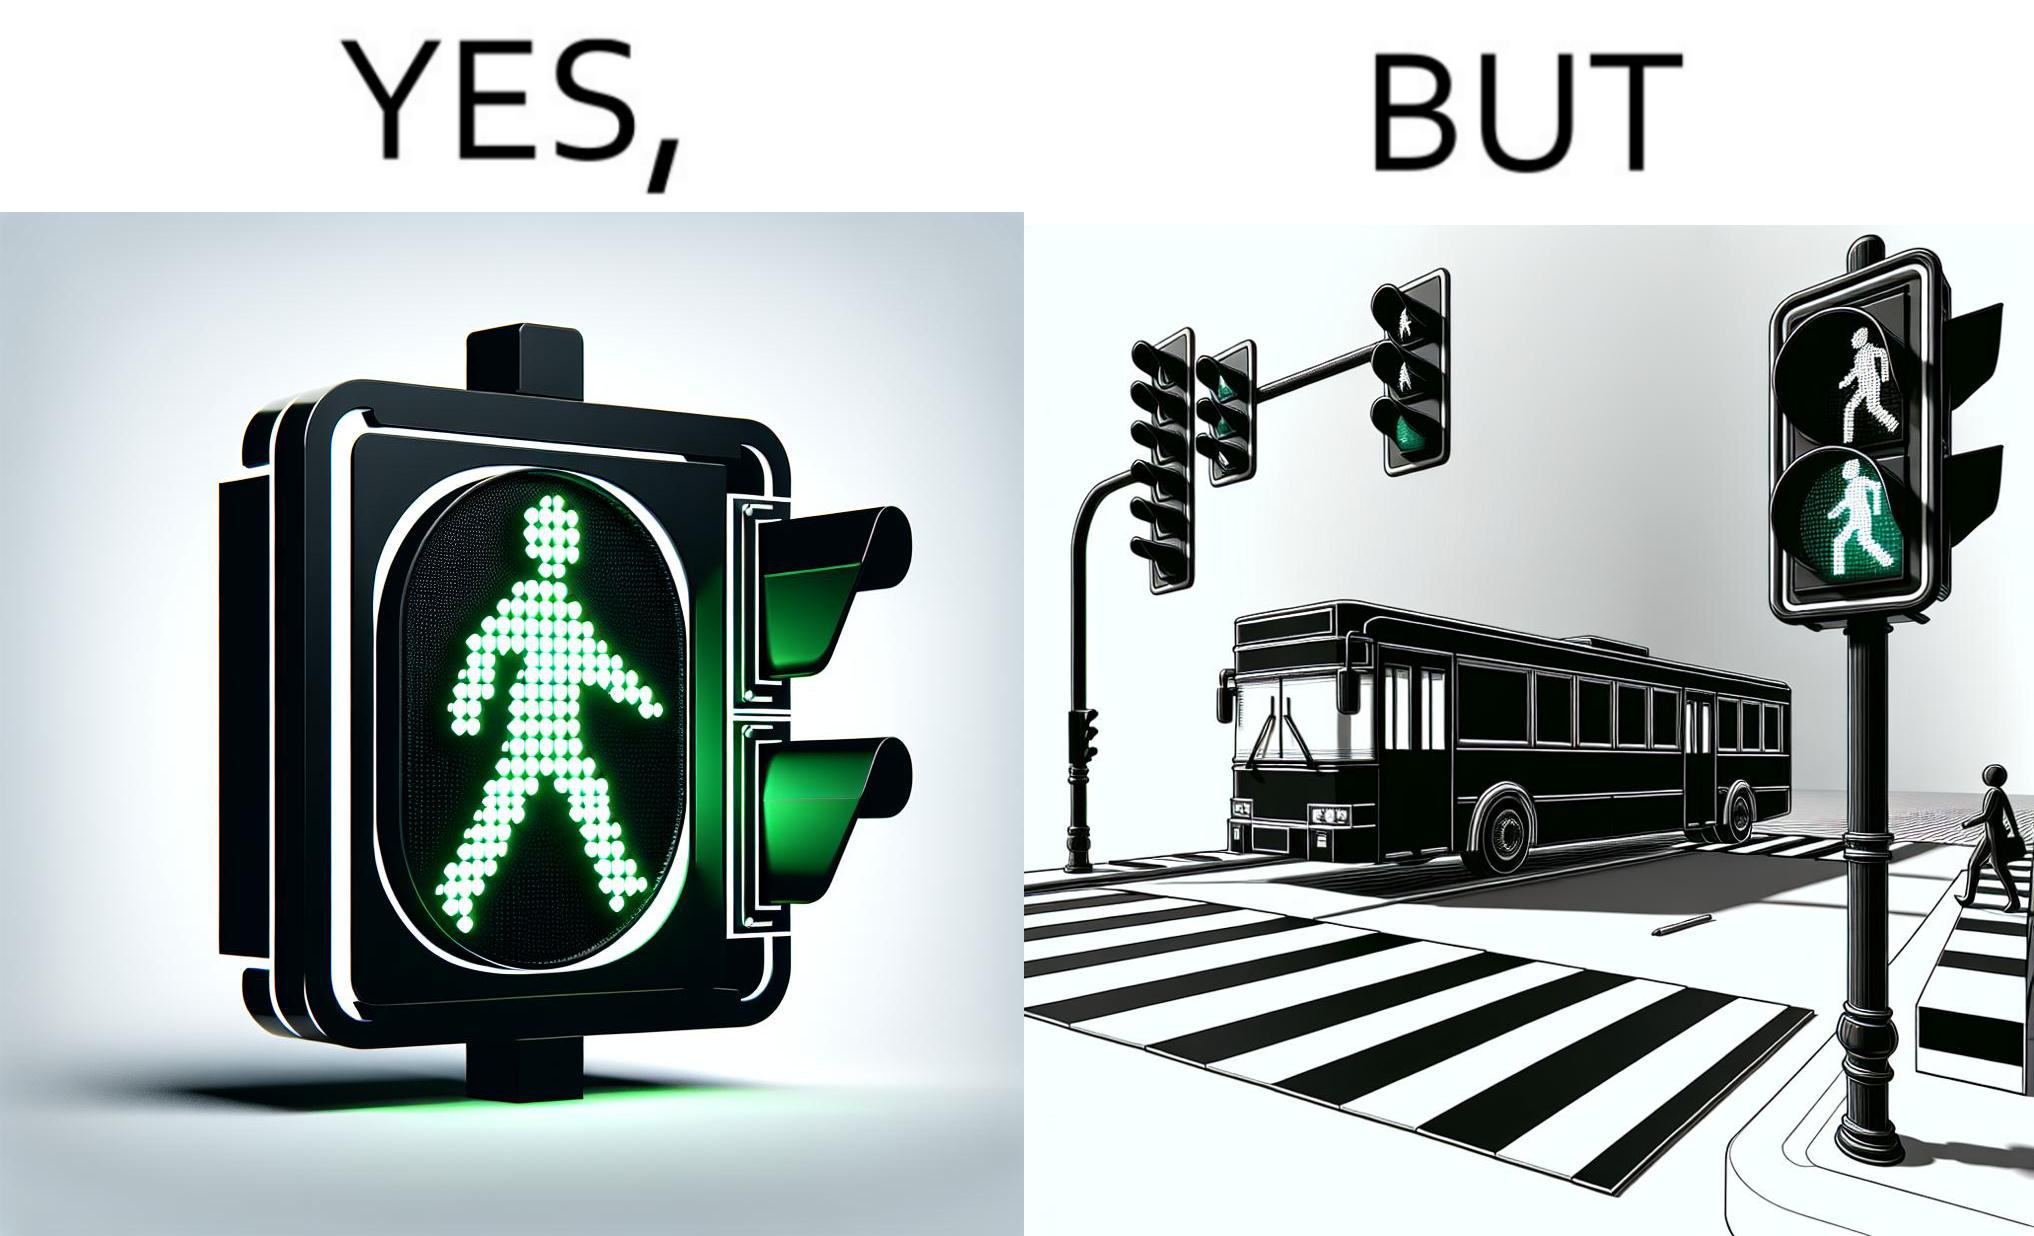Describe what you see in the left and right parts of this image. In the left part of the image: a traffic signal for the pedestrians and the signal is green, so pedestrians can cross the road In the right part of the image: a bus standing on the zebra crossing, while the traffic signal is green for the pedestrians symbolising  they can cross the road now 